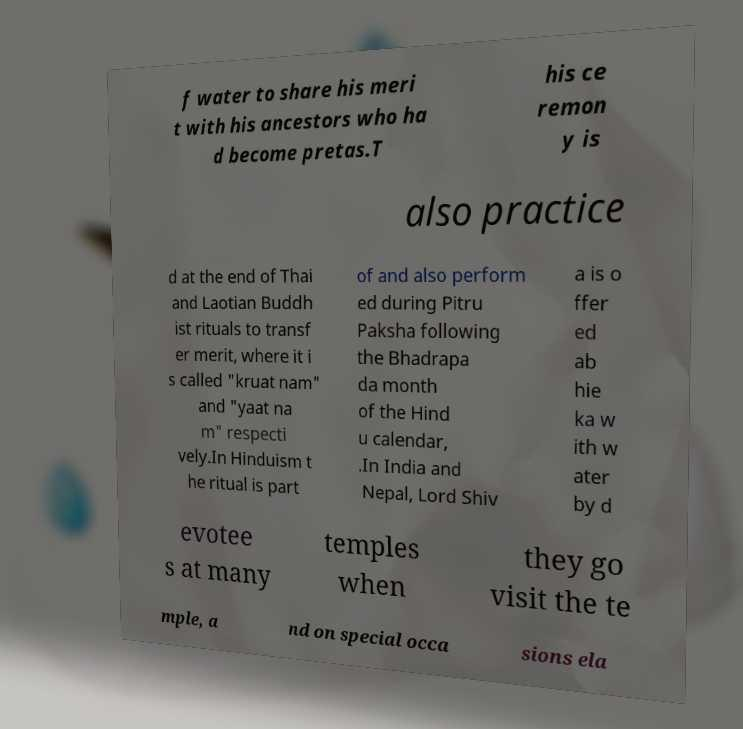Please read and relay the text visible in this image. What does it say? f water to share his meri t with his ancestors who ha d become pretas.T his ce remon y is also practice d at the end of Thai and Laotian Buddh ist rituals to transf er merit, where it i s called "kruat nam" and "yaat na m" respecti vely.In Hinduism t he ritual is part of and also perform ed during Pitru Paksha following the Bhadrapa da month of the Hind u calendar, .In India and Nepal, Lord Shiv a is o ffer ed ab hie ka w ith w ater by d evotee s at many temples when they go visit the te mple, a nd on special occa sions ela 